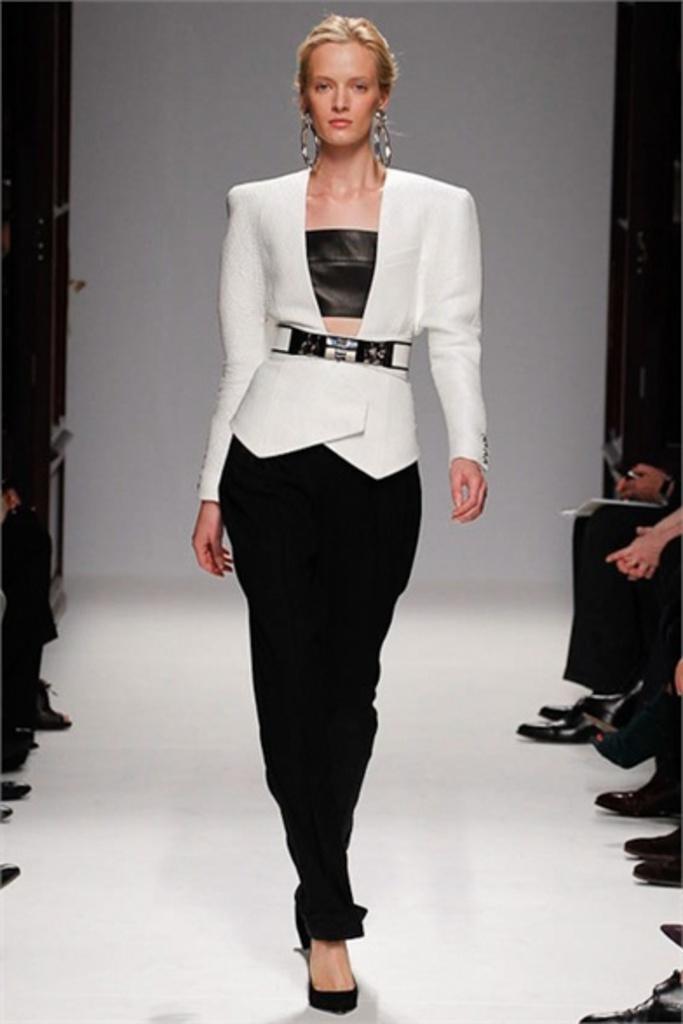Could you give a brief overview of what you see in this image? In this image on the left and right side, I can see some people. In the middle I can see a woman. In the background, I can see the wall. 